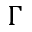Convert formula to latex. <formula><loc_0><loc_0><loc_500><loc_500>\Gamma</formula> 